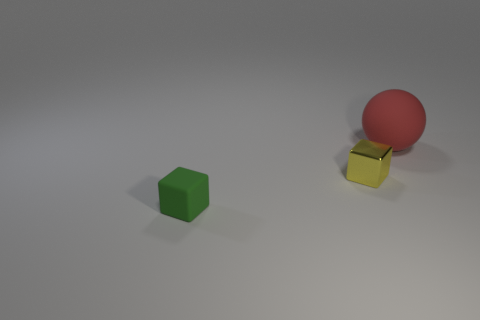Add 2 tiny yellow shiny objects. How many objects exist? 5 Subtract all yellow cubes. How many cubes are left? 1 Add 2 yellow rubber cylinders. How many yellow rubber cylinders exist? 2 Subtract 0 green cylinders. How many objects are left? 3 Subtract all spheres. How many objects are left? 2 Subtract all brown balls. Subtract all cyan cubes. How many balls are left? 1 Subtract all cyan balls. How many yellow cubes are left? 1 Subtract all tiny metallic things. Subtract all metal objects. How many objects are left? 1 Add 3 small matte objects. How many small matte objects are left? 4 